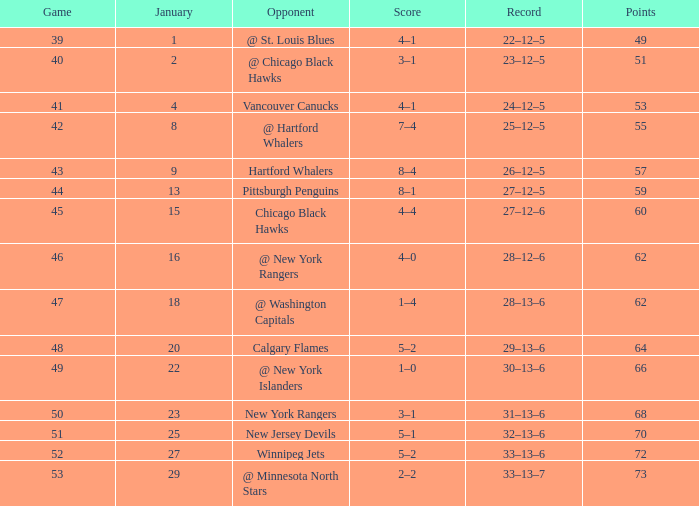Which Points have a Score of 4–1, and a Game smaller than 39? None. 